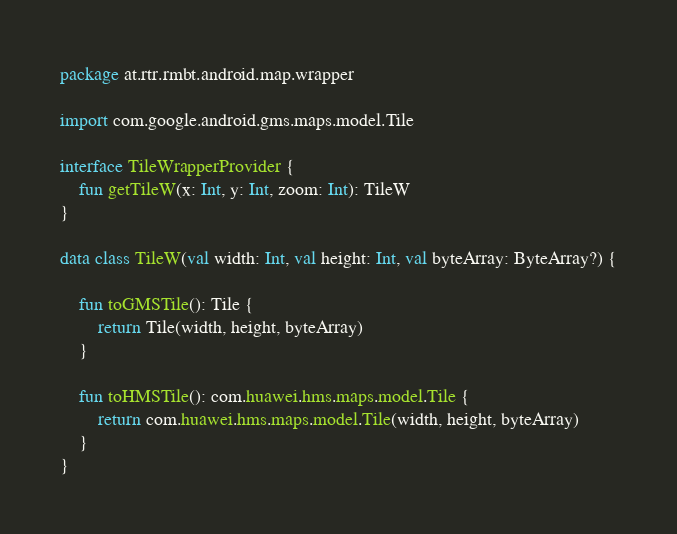Convert code to text. <code><loc_0><loc_0><loc_500><loc_500><_Kotlin_>package at.rtr.rmbt.android.map.wrapper

import com.google.android.gms.maps.model.Tile

interface TileWrapperProvider {
    fun getTileW(x: Int, y: Int, zoom: Int): TileW
}

data class TileW(val width: Int, val height: Int, val byteArray: ByteArray?) {

    fun toGMSTile(): Tile {
        return Tile(width, height, byteArray)
    }

    fun toHMSTile(): com.huawei.hms.maps.model.Tile {
        return com.huawei.hms.maps.model.Tile(width, height, byteArray)
    }
}</code> 